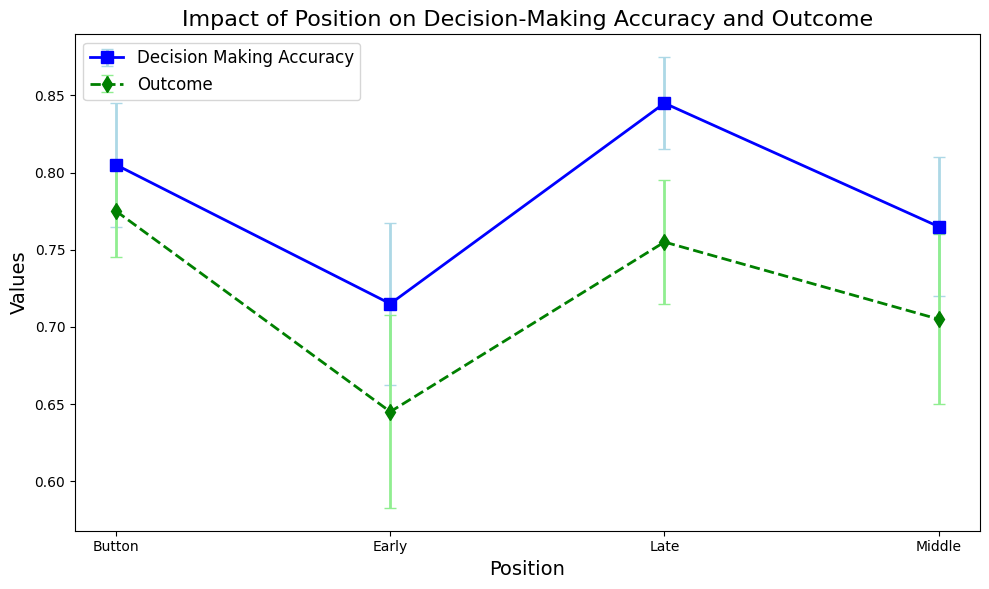What's the average Decision Making Accuracy for the Middle and Late positions? To find the average Decision Making Accuracy for the Middle and Late positions, add the mean accuracies of these positions and then divide by 2. The Middle position has an average accuracy of 0.765, and the Late position has an average accuracy of 0.845. So, (0.765 + 0.845) / 2 = 0.805.
Answer: 0.805 Which position shows the highest average Outcome? According to the figure, the Button position has the highest average Outcome value.
Answer: Button How does the error margin of Decision Making Accuracy in the Early position compare to the Late position? The figure shows that the error margin for the Decision Making Accuracy in the Early position is wider than that of the Late position. Early position error bar is larger than Late position error bar.
Answer: Early is wider What is the difference in average Decision Making Accuracy between the Button and Early positions? First, find the average Decision Making Accuracy for the Button and Early positions. For the Button, it is 0.805, and for the Early position, it is 0.715. The difference is 0.805 - 0.715 = 0.09.
Answer: 0.09 Is the average Outcome of positions ever higher than their corresponding Decision Making Accuracy? No, for all positions, the average Outcome is less than or equal to the Decision Making Accuracy.
Answer: No Which position has the smallest error margin in Outcome? The smallest error margin in Outcome is for the Button position.
Answer: Button Between which two positions is the average Decision Making Accuracy difference the smallest? The smallest difference in average Decision Making Accuracy is between the Middle (0.765) and Button (0.805) positions. The difference is 0.805 - 0.765 = 0.04.
Answer: Middle and Button Which metric has a more consistent (smaller average error) trend: Decision Making Accuracy or Outcome? Outcome has a smaller average error across all positions compared to Decision Making Accuracy.
Answer: Outcome 